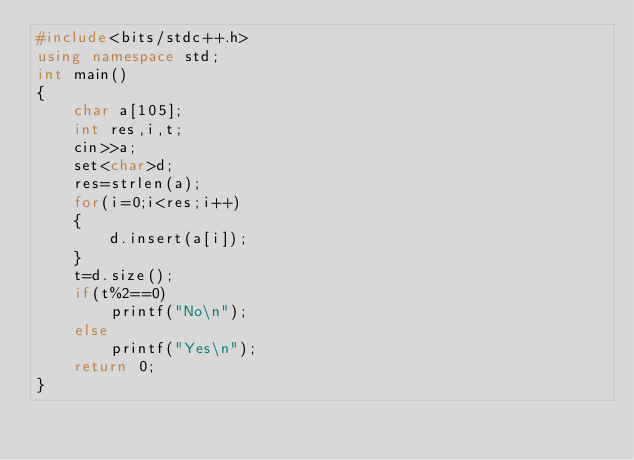Convert code to text. <code><loc_0><loc_0><loc_500><loc_500><_C++_>#include<bits/stdc++.h>
using namespace std;
int main()
{
    char a[105];
    int res,i,t;
    cin>>a;
    set<char>d;
    res=strlen(a);
    for(i=0;i<res;i++)
    {
        d.insert(a[i]);
    }
    t=d.size();
    if(t%2==0)
        printf("No\n");
    else
        printf("Yes\n");
    return 0;
}
</code> 